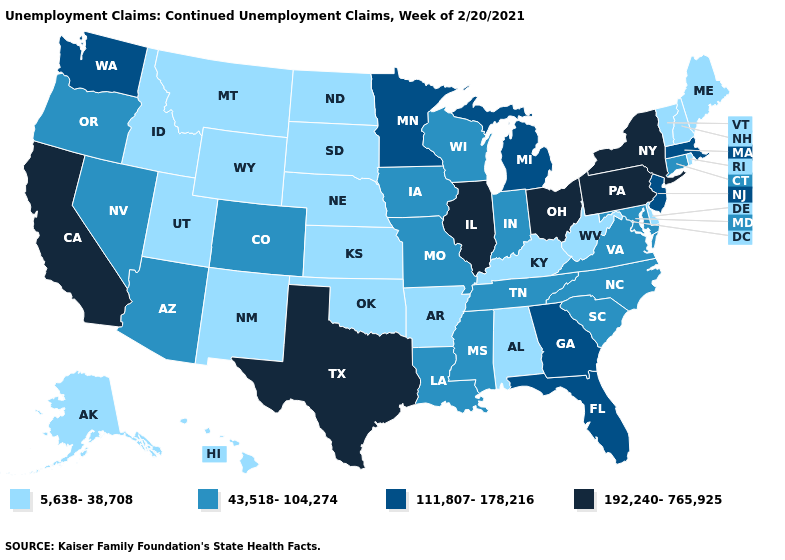Does Delaware have the same value as Idaho?
Write a very short answer. Yes. Which states have the highest value in the USA?
Short answer required. California, Illinois, New York, Ohio, Pennsylvania, Texas. Name the states that have a value in the range 111,807-178,216?
Short answer required. Florida, Georgia, Massachusetts, Michigan, Minnesota, New Jersey, Washington. Which states have the highest value in the USA?
Answer briefly. California, Illinois, New York, Ohio, Pennsylvania, Texas. Name the states that have a value in the range 111,807-178,216?
Give a very brief answer. Florida, Georgia, Massachusetts, Michigan, Minnesota, New Jersey, Washington. Which states have the highest value in the USA?
Keep it brief. California, Illinois, New York, Ohio, Pennsylvania, Texas. What is the lowest value in states that border Rhode Island?
Concise answer only. 43,518-104,274. Name the states that have a value in the range 5,638-38,708?
Write a very short answer. Alabama, Alaska, Arkansas, Delaware, Hawaii, Idaho, Kansas, Kentucky, Maine, Montana, Nebraska, New Hampshire, New Mexico, North Dakota, Oklahoma, Rhode Island, South Dakota, Utah, Vermont, West Virginia, Wyoming. Name the states that have a value in the range 5,638-38,708?
Answer briefly. Alabama, Alaska, Arkansas, Delaware, Hawaii, Idaho, Kansas, Kentucky, Maine, Montana, Nebraska, New Hampshire, New Mexico, North Dakota, Oklahoma, Rhode Island, South Dakota, Utah, Vermont, West Virginia, Wyoming. What is the value of Arkansas?
Keep it brief. 5,638-38,708. Which states hav the highest value in the West?
Be succinct. California. What is the lowest value in states that border Florida?
Give a very brief answer. 5,638-38,708. Name the states that have a value in the range 192,240-765,925?
Write a very short answer. California, Illinois, New York, Ohio, Pennsylvania, Texas. What is the highest value in states that border Iowa?
Give a very brief answer. 192,240-765,925. 